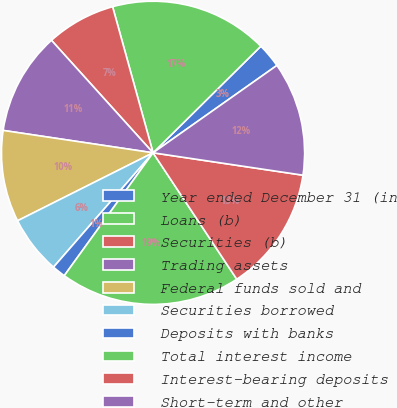<chart> <loc_0><loc_0><loc_500><loc_500><pie_chart><fcel>Year ended December 31 (in<fcel>Loans (b)<fcel>Securities (b)<fcel>Trading assets<fcel>Federal funds sold and<fcel>Securities borrowed<fcel>Deposits with banks<fcel>Total interest income<fcel>Interest-bearing deposits<fcel>Short-term and other<nl><fcel>2.63%<fcel>16.89%<fcel>7.39%<fcel>10.95%<fcel>9.76%<fcel>6.2%<fcel>1.44%<fcel>19.27%<fcel>13.33%<fcel>12.14%<nl></chart> 